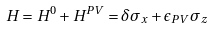<formula> <loc_0><loc_0><loc_500><loc_500>H = H ^ { 0 } + H ^ { P V } = \delta \sigma _ { x } + \epsilon _ { P V } \sigma _ { z }</formula> 